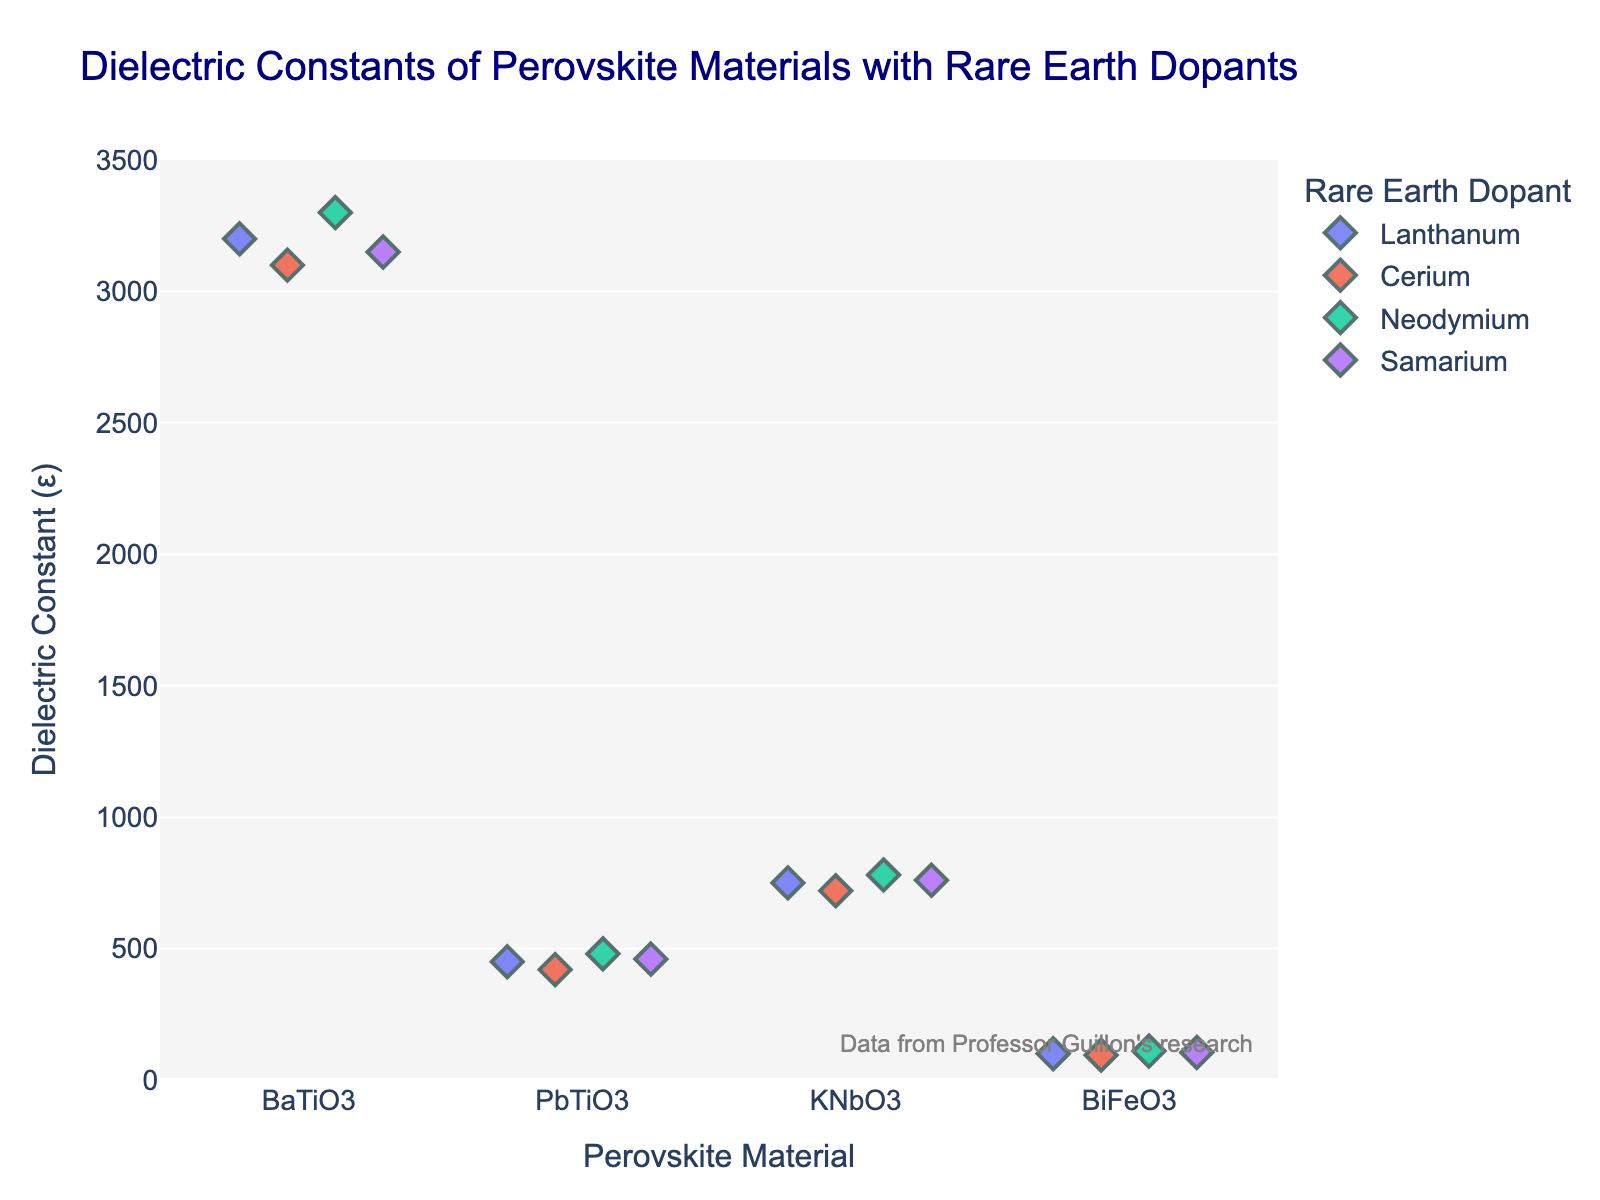what is the title of the plot? The title of the plot is located at the top center of the figure. It's meant to provide a succinct summary of the data being visualized.
Answer: "Dielectric Constants of Perovskite Materials with Rare Earth Dopants" How many perovskite materials are analyzed in the plot? By looking along the x-axis, we can count the unique labels representing each perovskite material.
Answer: 4 Which perovskite material exhibits the highest dielectric constant? By identifying the highest point along the y-axis and tracing it back to the x-axis, we can determine the material.
Answer: BaTiO3 How does the dielectric constant of PbTiO3 doped with Neodymium compare to when doped with Lanthanum? We find and compare the points for PbTiO3 with Neodymium and Lanthanum on the y-axis. Neodymium's value is higher.
Answer: Higher What is the average dielectric constant of BiFeO3 for all its dopants? We sum the dielectric constants for BiFeO3 with all dopants (100 + 95 + 110 + 105) and divide by the number of dopants (4). (100 + 95 + 110 + 105)/4 = 102.5
Answer: 102.5 Which rare earth dopant generally results in the highest dielectric constants across all materials? By identifying the highest points for each dopant across all perovskite materials, we see Neodymium consistently has higher values.
Answer: Neodymium What is the range of dielectric constants for KNbO3? We identify and calculate the difference between the highest (Neodymium, 780) and lowest (Cerium, 720) dielectric constants for KNbO3. 780 - 720 = 60
Answer: 60 Do any materials share identical dielectric constant values with different dopants? We look for points on the plot that align horizontally, indicating identical dielectric constants across different dopants. None of them align perfectly.
Answer: No 